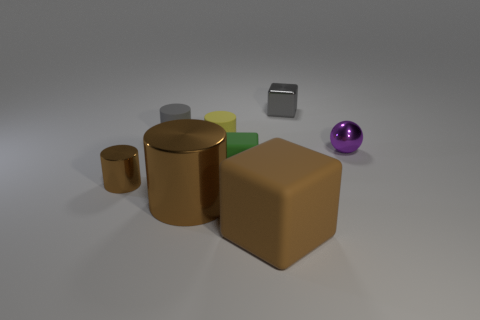Subtract all brown cubes. How many cubes are left? 2 Add 1 small brown metallic cylinders. How many objects exist? 9 Subtract all gray cylinders. How many cylinders are left? 3 Subtract all purple spheres. How many brown cylinders are left? 2 Add 2 small metal cylinders. How many small metal cylinders are left? 3 Add 6 tiny cyan metallic cylinders. How many tiny cyan metallic cylinders exist? 6 Subtract 0 red spheres. How many objects are left? 8 Subtract all blocks. How many objects are left? 5 Subtract 1 cubes. How many cubes are left? 2 Subtract all green cubes. Subtract all green cylinders. How many cubes are left? 2 